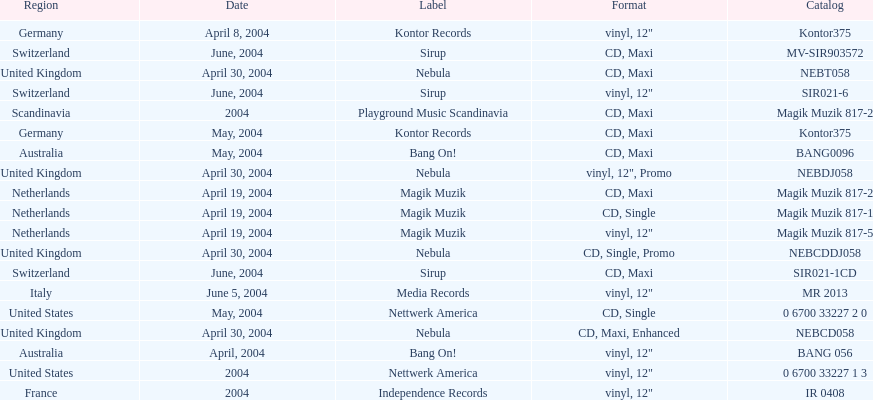What region is above australia? Germany. 